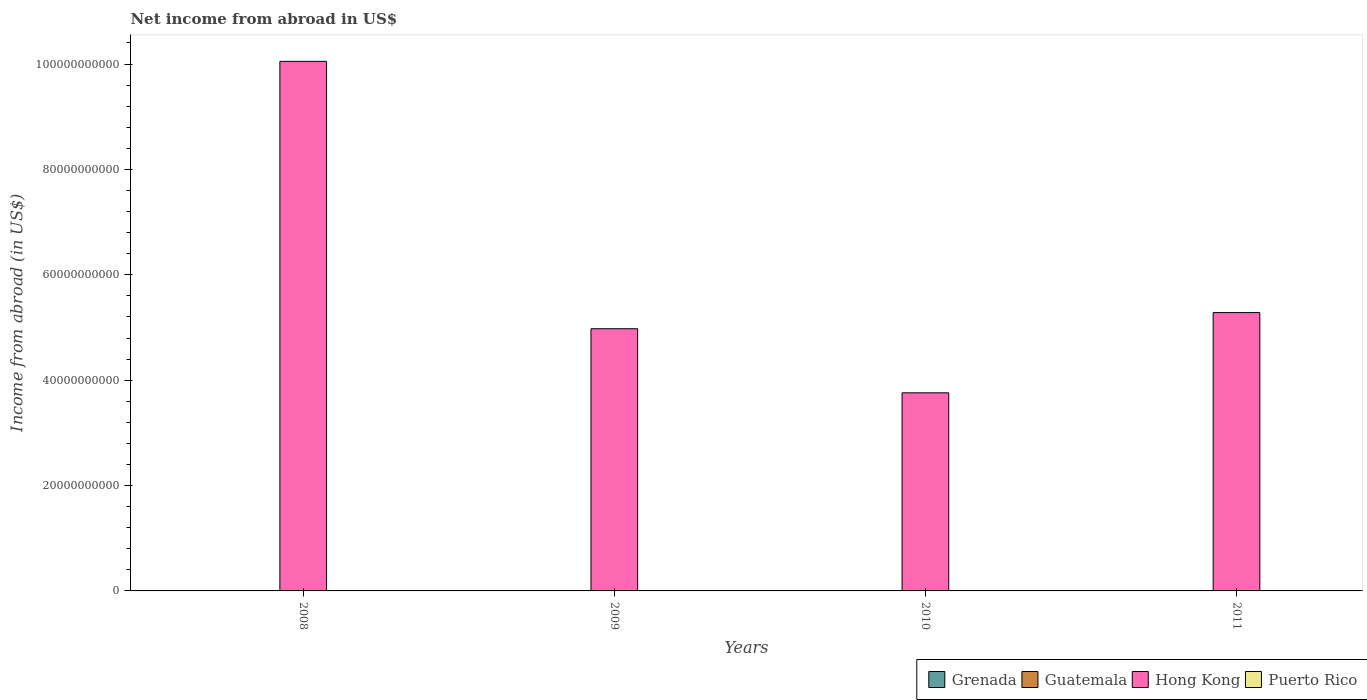How many different coloured bars are there?
Your response must be concise. 1. How many bars are there on the 3rd tick from the left?
Ensure brevity in your answer.  1. How many bars are there on the 3rd tick from the right?
Provide a short and direct response. 1. Across all years, what is the minimum net income from abroad in Grenada?
Your response must be concise. 0. In which year was the net income from abroad in Hong Kong maximum?
Give a very brief answer. 2008. What is the difference between the net income from abroad in Hong Kong in 2010 and that in 2011?
Give a very brief answer. -1.52e+1. What is the average net income from abroad in Guatemala per year?
Your answer should be very brief. 0. What is the ratio of the net income from abroad in Hong Kong in 2009 to that in 2011?
Your answer should be very brief. 0.94. Is the net income from abroad in Hong Kong in 2008 less than that in 2009?
Ensure brevity in your answer.  No. What is the difference between the highest and the second highest net income from abroad in Hong Kong?
Keep it short and to the point. 4.77e+1. What is the difference between the highest and the lowest net income from abroad in Hong Kong?
Offer a very short reply. 6.29e+1. Is it the case that in every year, the sum of the net income from abroad in Puerto Rico and net income from abroad in Grenada is greater than the sum of net income from abroad in Guatemala and net income from abroad in Hong Kong?
Make the answer very short. No. How many bars are there?
Keep it short and to the point. 4. How many years are there in the graph?
Offer a terse response. 4. Are the values on the major ticks of Y-axis written in scientific E-notation?
Offer a terse response. No. Does the graph contain grids?
Your answer should be very brief. No. Where does the legend appear in the graph?
Provide a succinct answer. Bottom right. How many legend labels are there?
Provide a short and direct response. 4. What is the title of the graph?
Give a very brief answer. Net income from abroad in US$. Does "United States" appear as one of the legend labels in the graph?
Keep it short and to the point. No. What is the label or title of the X-axis?
Your response must be concise. Years. What is the label or title of the Y-axis?
Provide a short and direct response. Income from abroad (in US$). What is the Income from abroad (in US$) in Guatemala in 2008?
Provide a succinct answer. 0. What is the Income from abroad (in US$) in Hong Kong in 2008?
Provide a succinct answer. 1.01e+11. What is the Income from abroad (in US$) of Puerto Rico in 2008?
Keep it short and to the point. 0. What is the Income from abroad (in US$) of Grenada in 2009?
Your answer should be very brief. 0. What is the Income from abroad (in US$) in Hong Kong in 2009?
Make the answer very short. 4.98e+1. What is the Income from abroad (in US$) of Puerto Rico in 2009?
Provide a succinct answer. 0. What is the Income from abroad (in US$) in Grenada in 2010?
Keep it short and to the point. 0. What is the Income from abroad (in US$) in Hong Kong in 2010?
Give a very brief answer. 3.76e+1. What is the Income from abroad (in US$) of Puerto Rico in 2010?
Offer a terse response. 0. What is the Income from abroad (in US$) in Guatemala in 2011?
Provide a succinct answer. 0. What is the Income from abroad (in US$) in Hong Kong in 2011?
Ensure brevity in your answer.  5.28e+1. What is the Income from abroad (in US$) of Puerto Rico in 2011?
Make the answer very short. 0. Across all years, what is the maximum Income from abroad (in US$) in Hong Kong?
Keep it short and to the point. 1.01e+11. Across all years, what is the minimum Income from abroad (in US$) in Hong Kong?
Keep it short and to the point. 3.76e+1. What is the total Income from abroad (in US$) of Grenada in the graph?
Give a very brief answer. 0. What is the total Income from abroad (in US$) in Hong Kong in the graph?
Offer a very short reply. 2.41e+11. What is the total Income from abroad (in US$) in Puerto Rico in the graph?
Provide a succinct answer. 0. What is the difference between the Income from abroad (in US$) of Hong Kong in 2008 and that in 2009?
Make the answer very short. 5.07e+1. What is the difference between the Income from abroad (in US$) of Hong Kong in 2008 and that in 2010?
Ensure brevity in your answer.  6.29e+1. What is the difference between the Income from abroad (in US$) in Hong Kong in 2008 and that in 2011?
Give a very brief answer. 4.77e+1. What is the difference between the Income from abroad (in US$) of Hong Kong in 2009 and that in 2010?
Your answer should be compact. 1.22e+1. What is the difference between the Income from abroad (in US$) of Hong Kong in 2009 and that in 2011?
Your answer should be very brief. -3.06e+09. What is the difference between the Income from abroad (in US$) in Hong Kong in 2010 and that in 2011?
Your answer should be very brief. -1.52e+1. What is the average Income from abroad (in US$) of Guatemala per year?
Ensure brevity in your answer.  0. What is the average Income from abroad (in US$) in Hong Kong per year?
Make the answer very short. 6.02e+1. What is the average Income from abroad (in US$) of Puerto Rico per year?
Offer a very short reply. 0. What is the ratio of the Income from abroad (in US$) of Hong Kong in 2008 to that in 2009?
Offer a terse response. 2.02. What is the ratio of the Income from abroad (in US$) in Hong Kong in 2008 to that in 2010?
Offer a terse response. 2.67. What is the ratio of the Income from abroad (in US$) of Hong Kong in 2008 to that in 2011?
Your answer should be very brief. 1.9. What is the ratio of the Income from abroad (in US$) of Hong Kong in 2009 to that in 2010?
Your answer should be very brief. 1.32. What is the ratio of the Income from abroad (in US$) of Hong Kong in 2009 to that in 2011?
Offer a terse response. 0.94. What is the ratio of the Income from abroad (in US$) in Hong Kong in 2010 to that in 2011?
Your answer should be very brief. 0.71. What is the difference between the highest and the second highest Income from abroad (in US$) in Hong Kong?
Ensure brevity in your answer.  4.77e+1. What is the difference between the highest and the lowest Income from abroad (in US$) of Hong Kong?
Provide a short and direct response. 6.29e+1. 